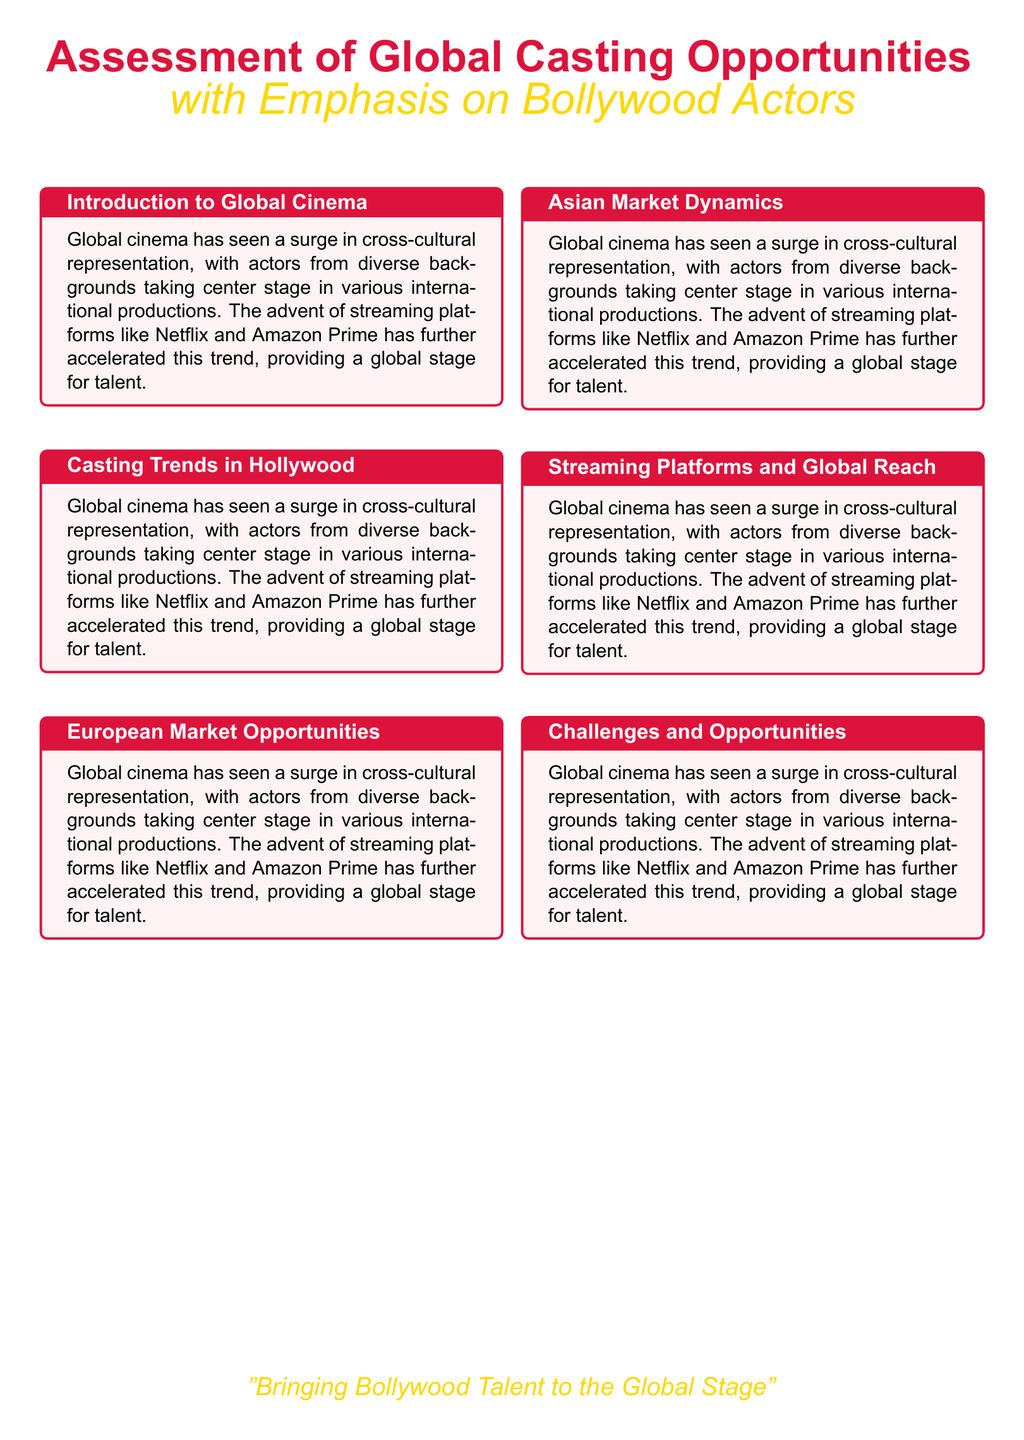What is the focus of the document? The document focuses on assessing global casting opportunities, particularly for Bollywood actors.
Answer: global casting opportunities Which Bollywood actor is mentioned as having a significant following in China? The document states that Aamir Khan's movies have grossed millions in China, indicating his popularity there.
Answer: Aamir Khan What platform is highlighted as pivotal for showcasing Bollywood actors internationally? The document mentions streaming services as being crucial for providing a global platform for Bollywood actors.
Answer: streaming services Name one Bollywood actor who has successfully transitioned to Hollywood. The document gives examples of successful transitions, mentioning Priyanka Chopra.
Answer: Priyanka Chopra What challenge is highlighted that Bollywood actors face in the global market? The document indicates that language barriers are one of the challenges Bollywood actors encounter.
Answer: language barriers Which streaming series featuring Indian talent is mentioned in the document? The document references 'Sacred Games' as a series that has received international acclaim.
Answer: Sacred Games What event is mentioned that helps enhance Bollywood actors' international success? The document references the 'International Indian Film Academy Awards' as an initiative aiding Bollywood actors.
Answer: International Indian Film Academy Awards In which international market are Bollywood actors seeing rising collaborations mentioned? The document notes that collaborations between Bollywood and regional cinema are increasing in Southeast Asia.
Answer: Southeast Asia 